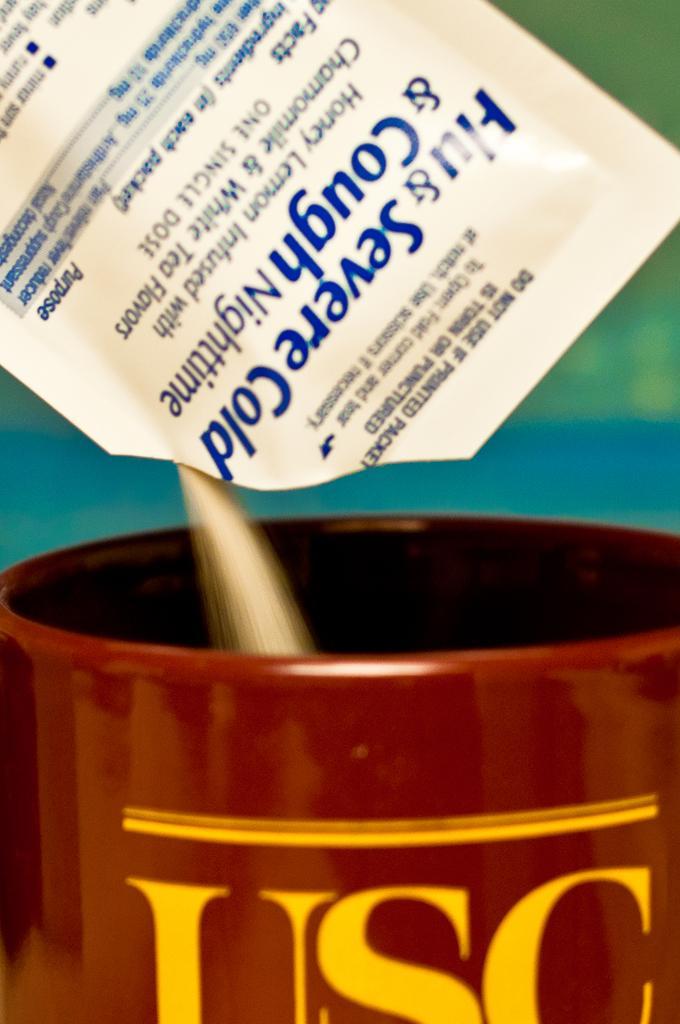Can you describe this image briefly? In this image I can see at the bottom there is the cup in brown color. At the top powder is falling from the packet. 